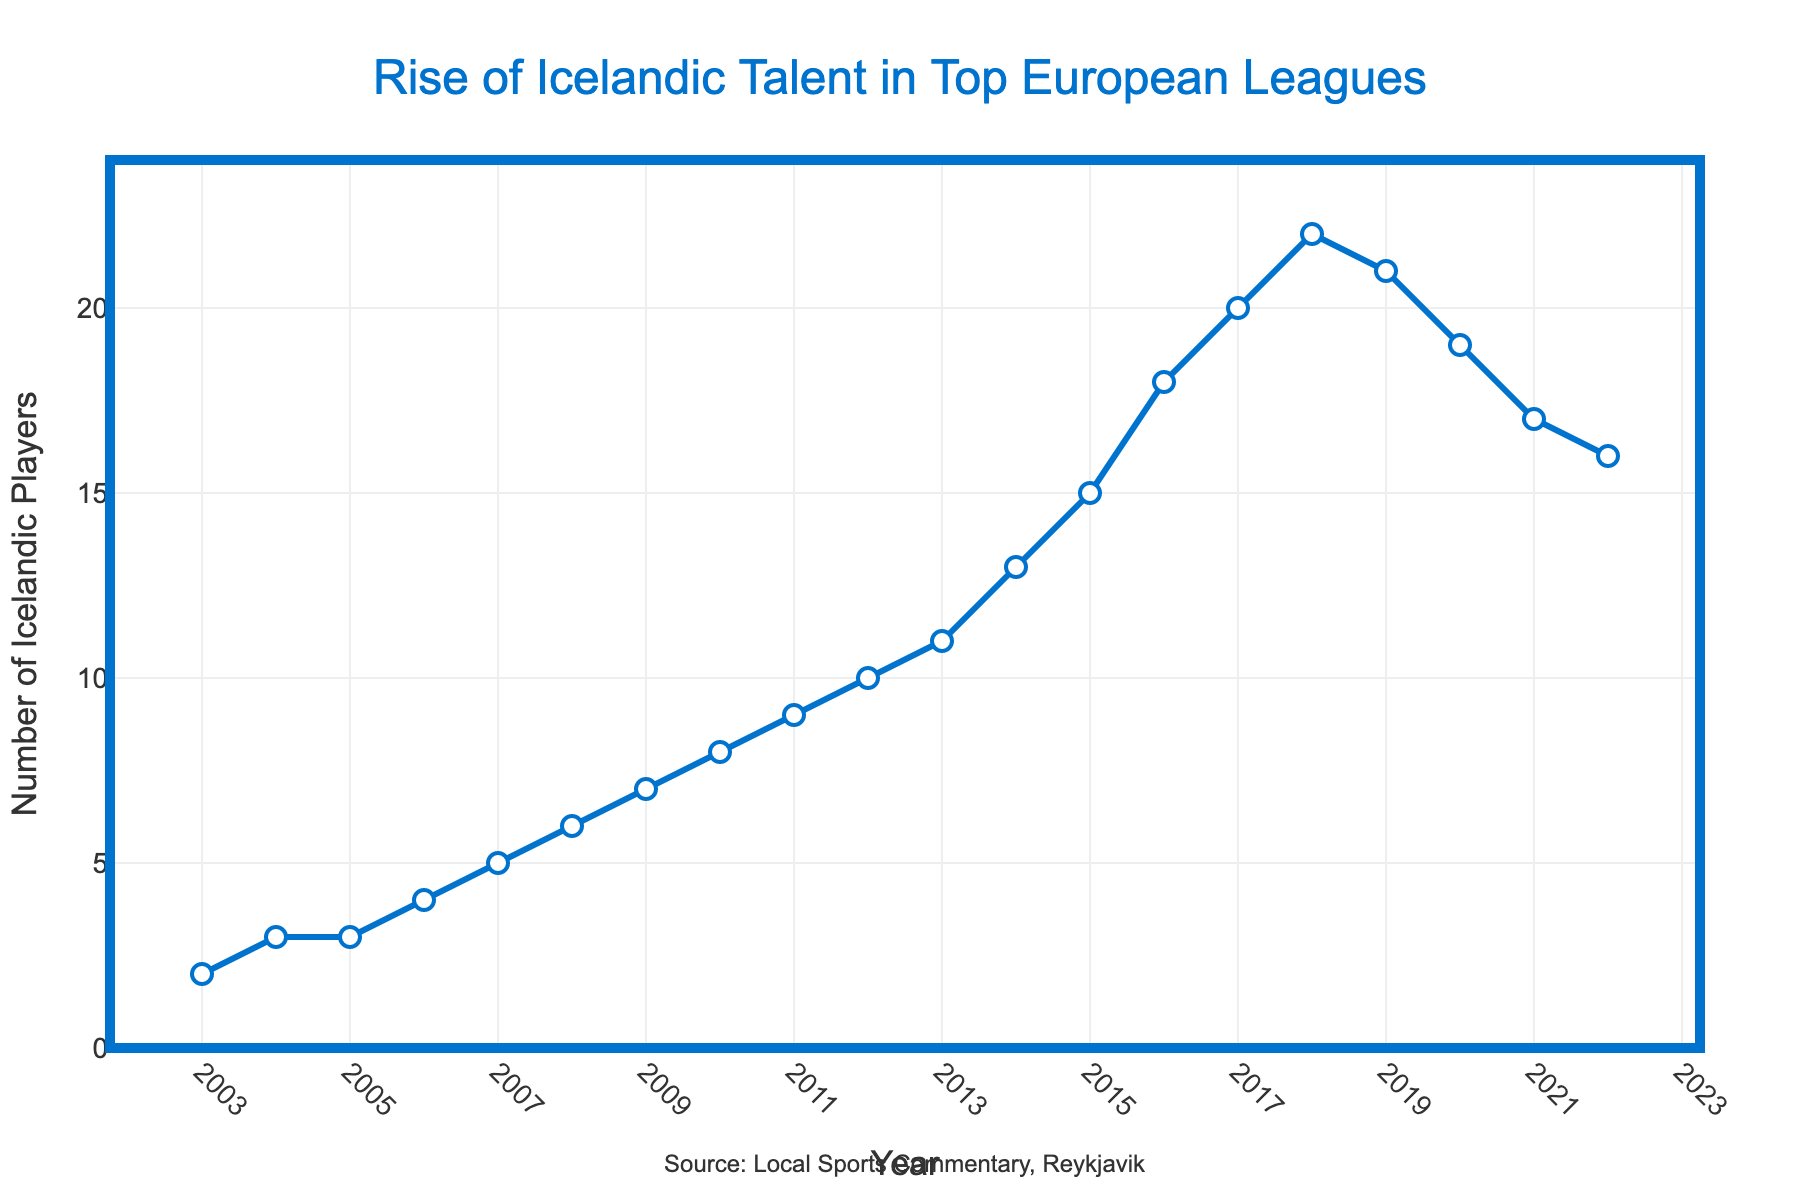What's the highest number of Icelandic players recorded at any point on the graph? The highest peak is observed at the year 2018 with 22 players, according to the "Number of Icelandic Players" axis.
Answer: 22 In which year did the number of Icelandic players first reach double digits (10 or more)? By looking at the "Number of Icelandic Players" axis, we see that the number of players first reached 10 in 2012.
Answer: 2012 What was the increase in the number of Icelandic players from 2003 to 2018? In 2003 the number was 2 players and in 2018 it was 22 players. The increase is calculated as 22 - 2 = 20 players.
Answer: 20 During which period did the number of Icelandic players decrease the most? The most significant decrease happens from 2018 to 2019, where the number falls from 22 to 21, resulting in a decrease of 1 player.
Answer: 2018 to 2019 What's the average number of Icelandic players from 2003 to 2022? Sum up the number of players for all the years (2+3+3+4+5+6+7+8+9+10+11+13+15+18+20+22+21+19+17+16 = 230) and divide by the total years (20), which results in 230/20 = 11.5.
Answer: 11.5 Which two consecutive years had the same number of Icelandic players? Observing the graph, the number of Icelandic players remains the same from 2004 to 2005 at 3 players.
Answer: 2004 and 2005 How many times did the number of Icelandic players exceed 15? From the graph, the years where the number of players exceeded 15 are 2015, 2016, 2017, 2018, 2019, 2020, 2021, and 2022, leading to a total of 8 times.
Answer: 8 Between what years did Icelandic players’ number see steady growth every year without any drop? The graph shows steady growth from 2006 to 2013 without any drop in the number of Icelandic players.
Answer: 2006 to 2013 What was the trend in the number of Icelandic players from 2015 to 2022? The number increased from 15 in 2015 to 22 in 2018 but then started to decrease to 16 in 2022.
Answer: Increased then decreased 